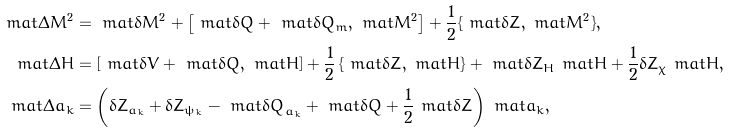Convert formula to latex. <formula><loc_0><loc_0><loc_500><loc_500>\ m a t { \Delta M ^ { 2 } } & = \ m a t { \delta M ^ { 2 } } + \left [ \ m a t { \delta Q } + \ m a t { \delta Q _ { m } } , \ m a t { M ^ { 2 } } \right ] + \frac { 1 } { 2 } \{ \ m a t { \delta Z } , \ m a t { M ^ { 2 } } \} , \\ \ m a t { \Delta H } & = \left [ \ m a t { \delta V } + \ m a t { \delta Q } , \ m a t { H } \right ] + \frac { 1 } { 2 } \left \{ \ m a t { \delta Z } , \ m a t { H } \right \} + \ m a t { \delta Z _ { H } } \ m a t { H } + \frac { 1 } { 2 } \delta Z _ { \chi } \ m a t { H } , \\ \ m a t { \Delta a } _ { k } & = \left ( \delta Z _ { a _ { k } } + \delta Z _ { \psi _ { k } } - \ m a t { \delta Q } _ { a _ { k } } + \ m a t { \delta Q } + \frac { 1 } { 2 } \ m a t { \delta Z } \right ) \ m a t { a } _ { k } ,</formula> 